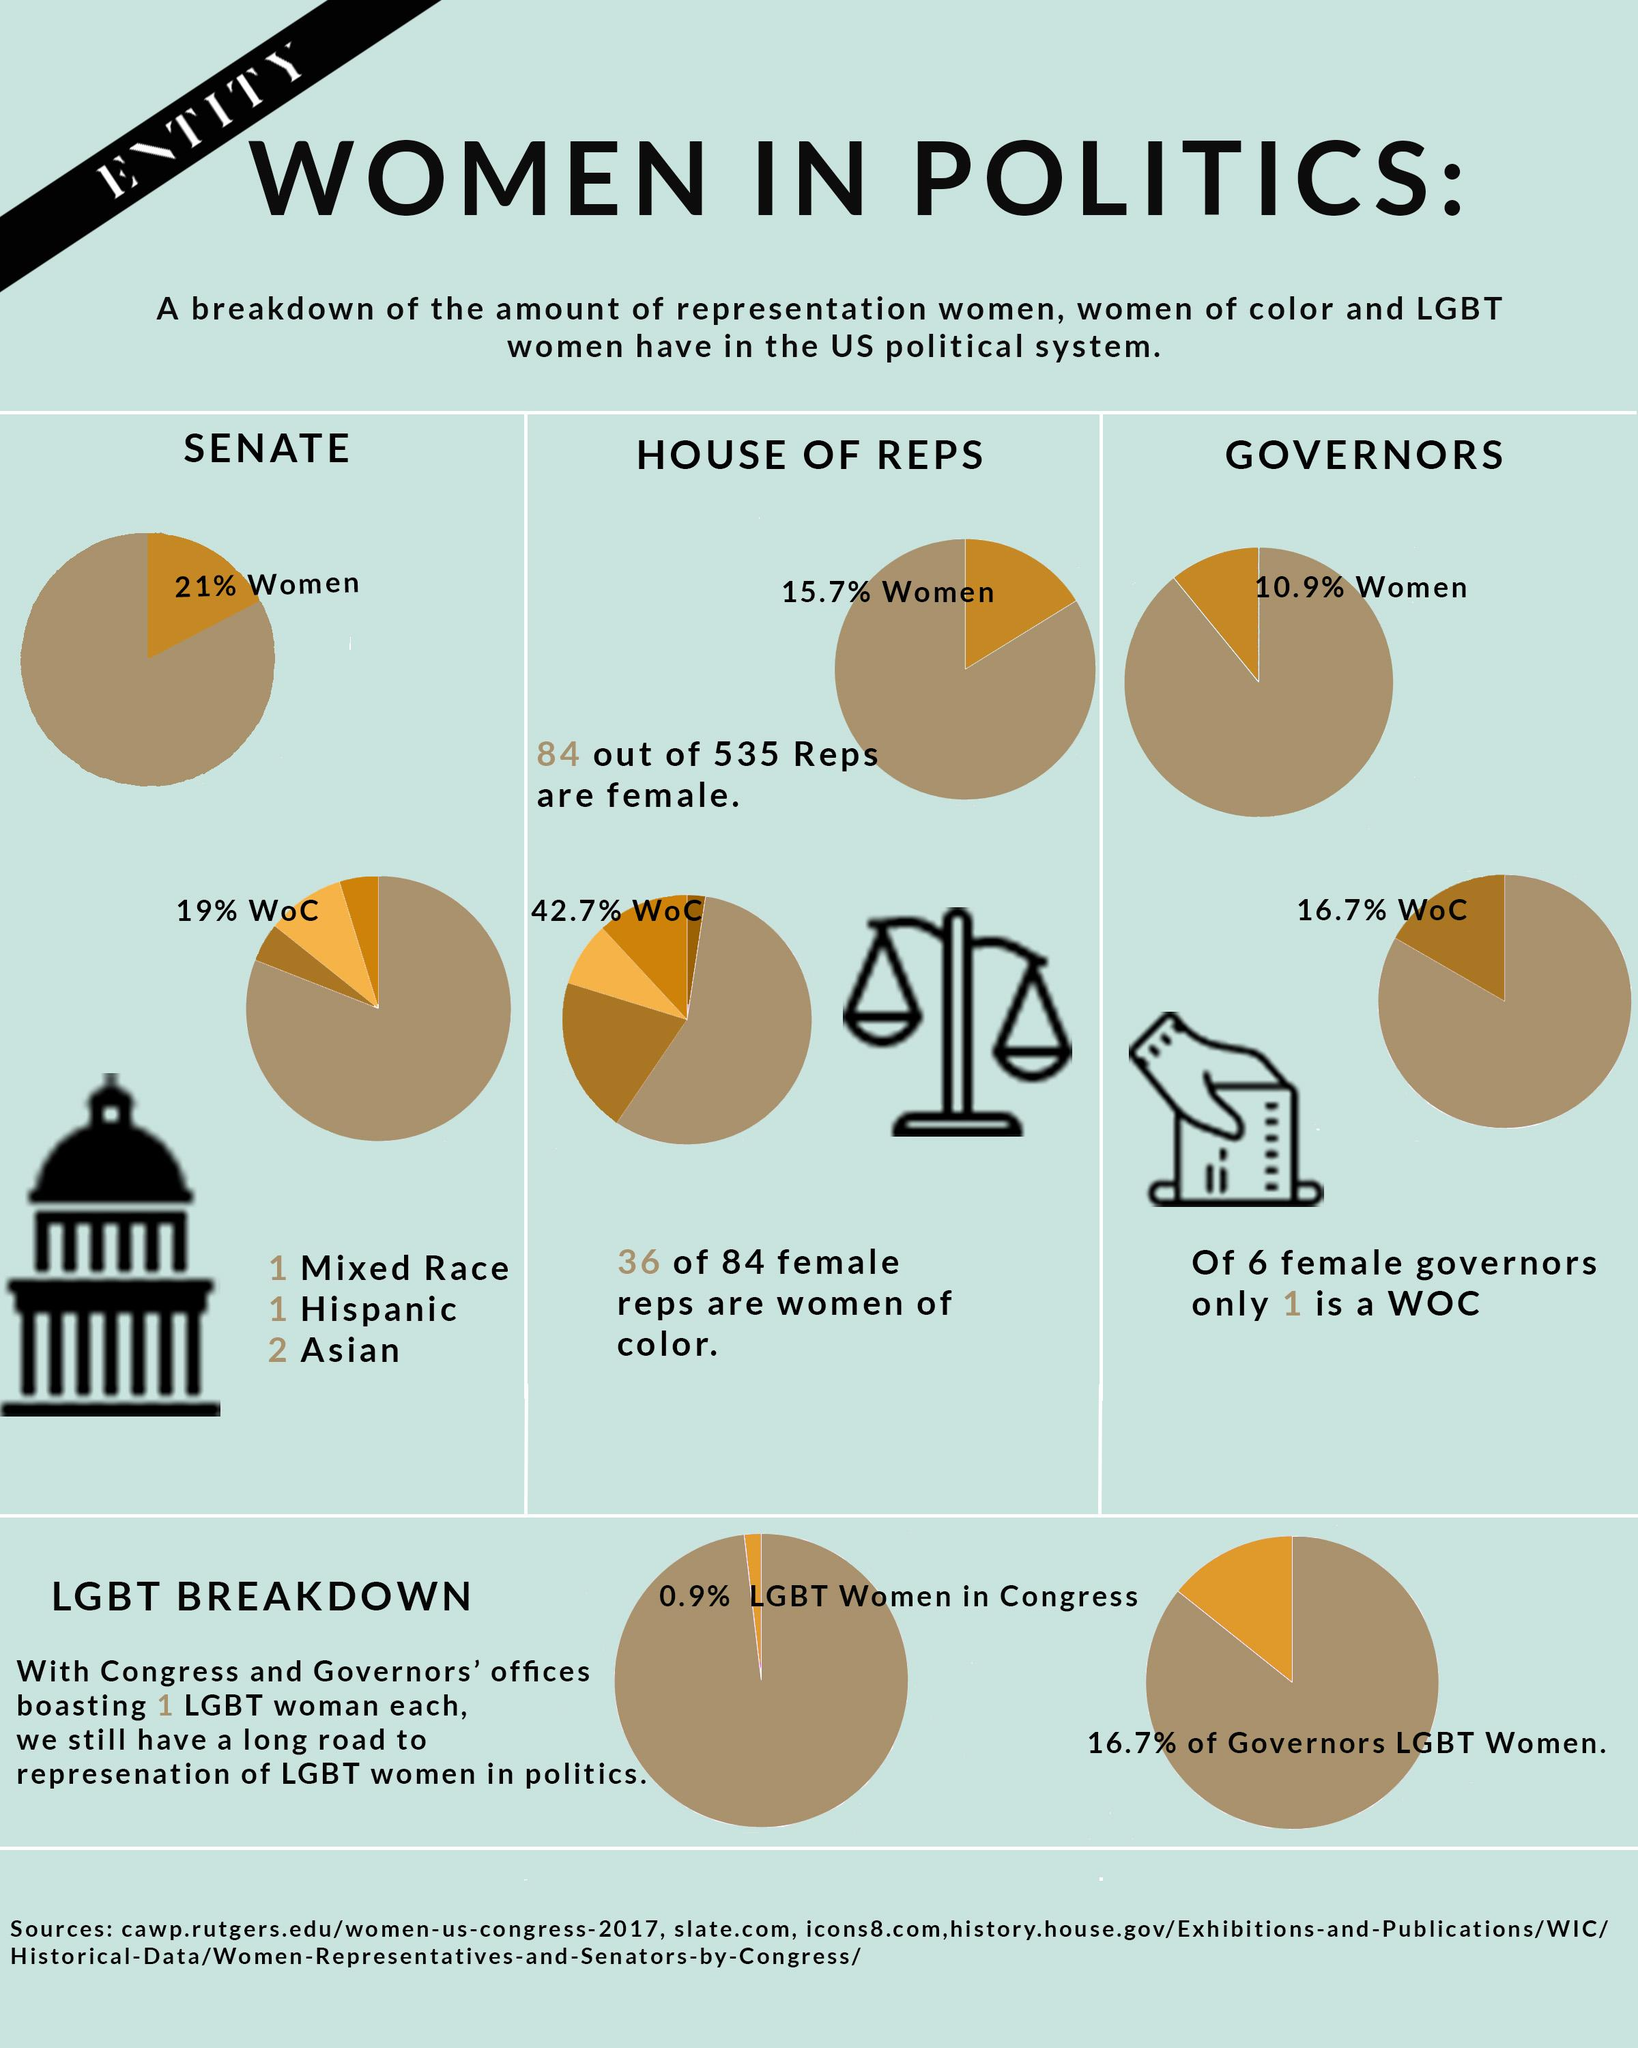Mention a couple of crucial points in this snapshot. Women of Color (WOC) is comprised of individuals who identify as mixed race, Hispanic, and Asian. Out of the total number of representatives, a specific number, which is 451, are not female. Only 79 out of 100 members of the Senate are not women. 